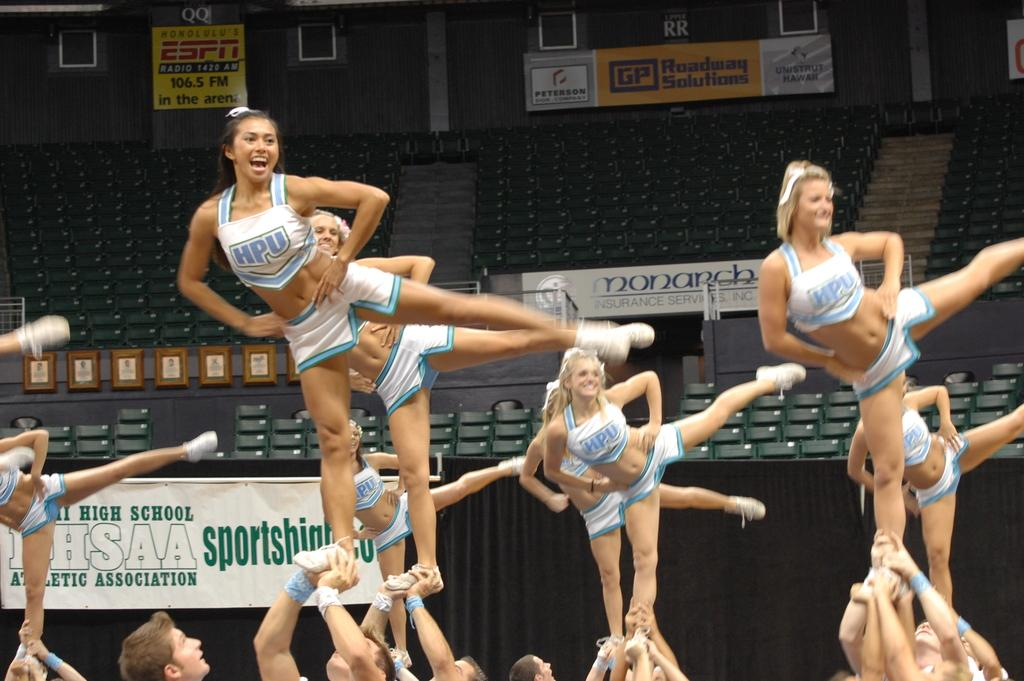Provide a one-sentence caption for the provided image. A group of cheerleaders from HPU are doing a routine. 